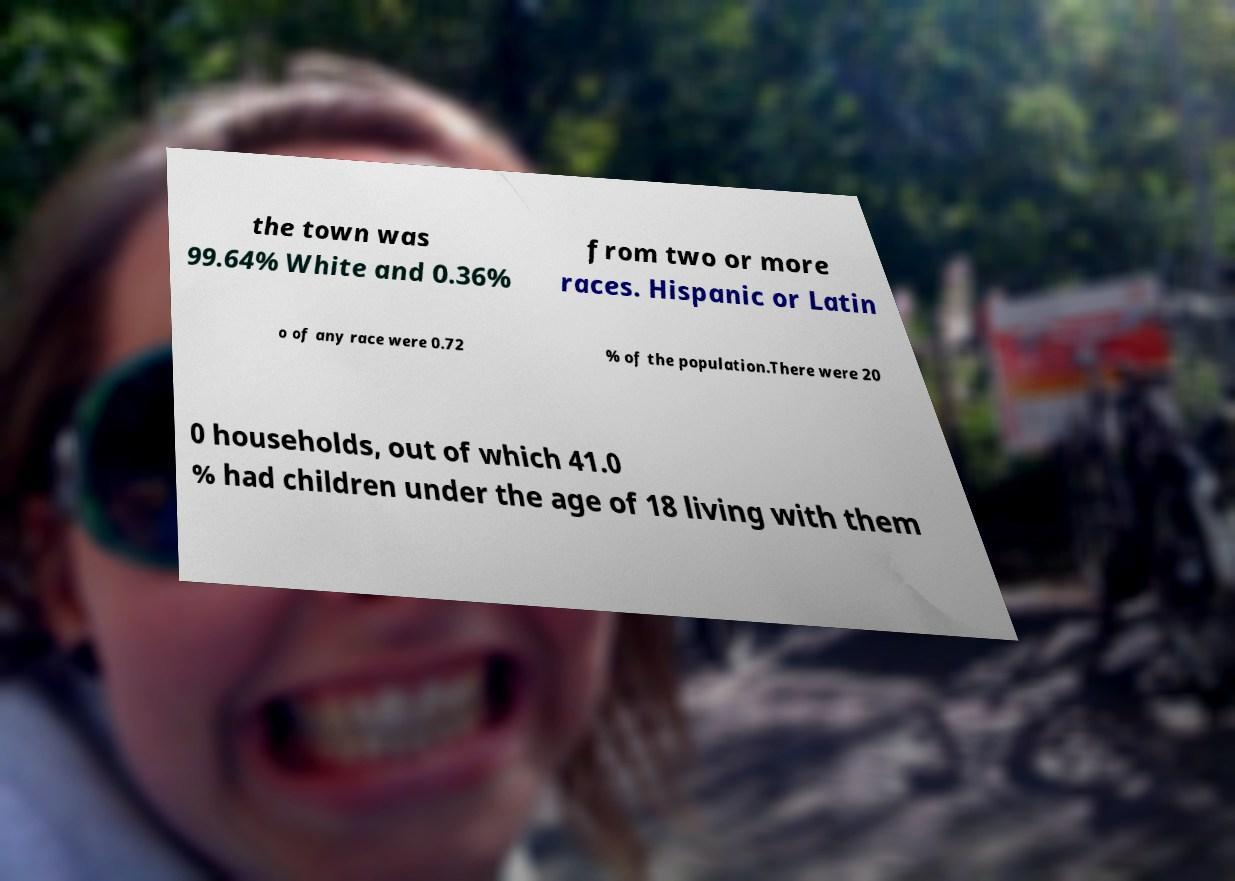Could you extract and type out the text from this image? the town was 99.64% White and 0.36% from two or more races. Hispanic or Latin o of any race were 0.72 % of the population.There were 20 0 households, out of which 41.0 % had children under the age of 18 living with them 